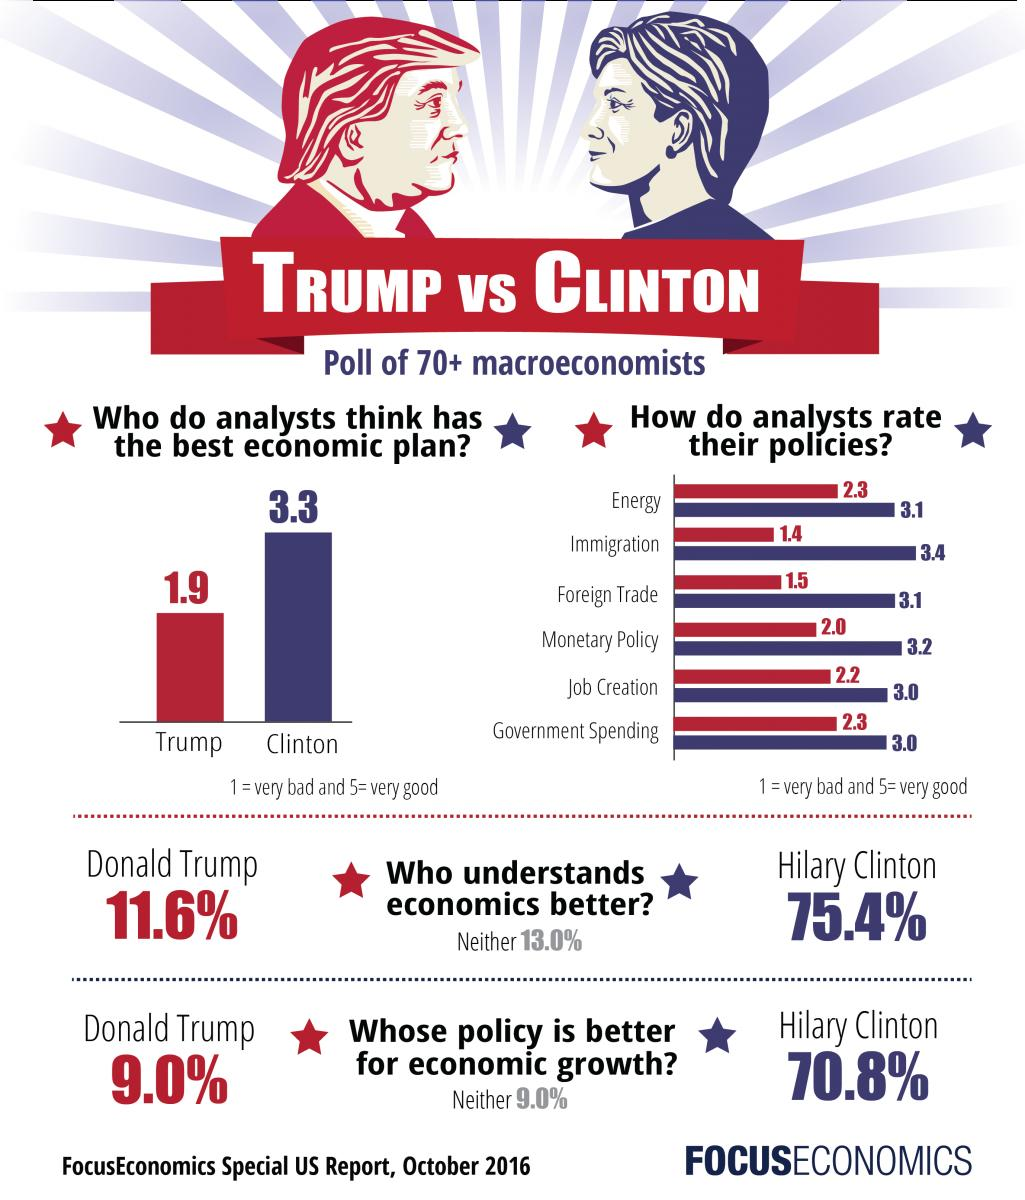Point out several critical features in this image. Hilary's economic plan is considered superior to Trump's. According to a survey, 75.4% of people believe that Hillary Clinton understands economics better than Donald Trump. A survey conducted found that 75.4% of people believe Trump's policies are better for economic growth, while 9.0% of the surveyed population disagree. Additionally, 70.8% of the participants in the survey expressed support for Trump's policies, with just 9.0% of respondents expressing dissatisfaction. Barack Obama has a better rating on the policy for job creation than Donald Trump or Hilary Clinton. 